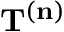Convert formula to latex. <formula><loc_0><loc_0><loc_500><loc_500>T ^ { ( n ) }</formula> 